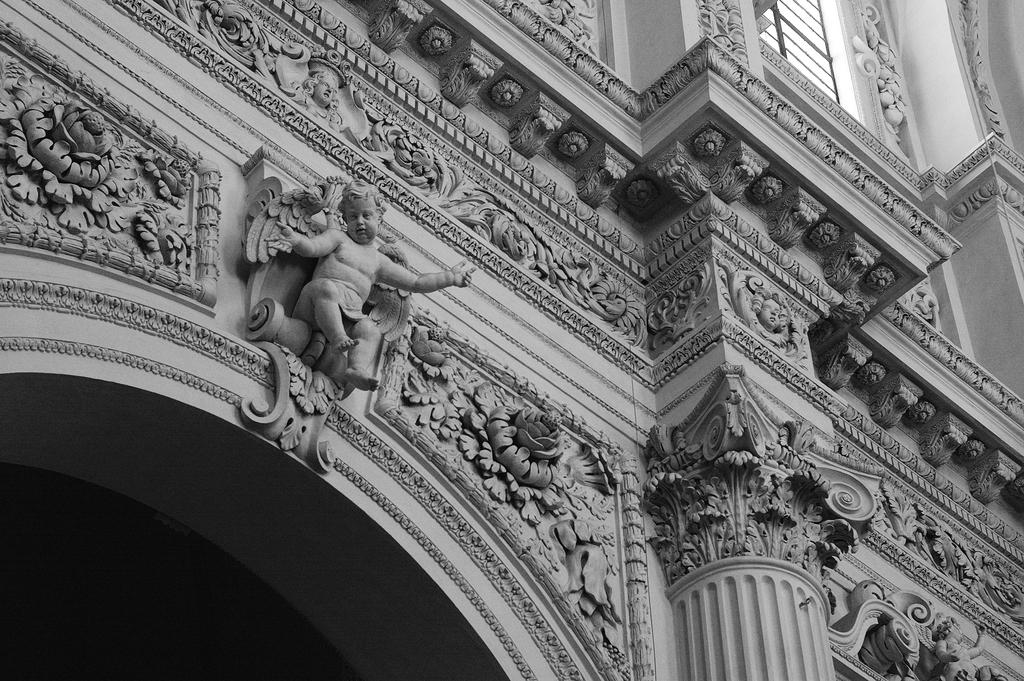What type of structure is visible in the image? There is a building in the image. What can be seen on the walls of the building? There is art on the walls of the building. Can you describe a specific piece of art on the building? There is a sculpture of a boy on the wall of the building. What is the rate of the vessel's movement in the image? There is no vessel present in the image, so it is not possible to determine its rate of movement. 